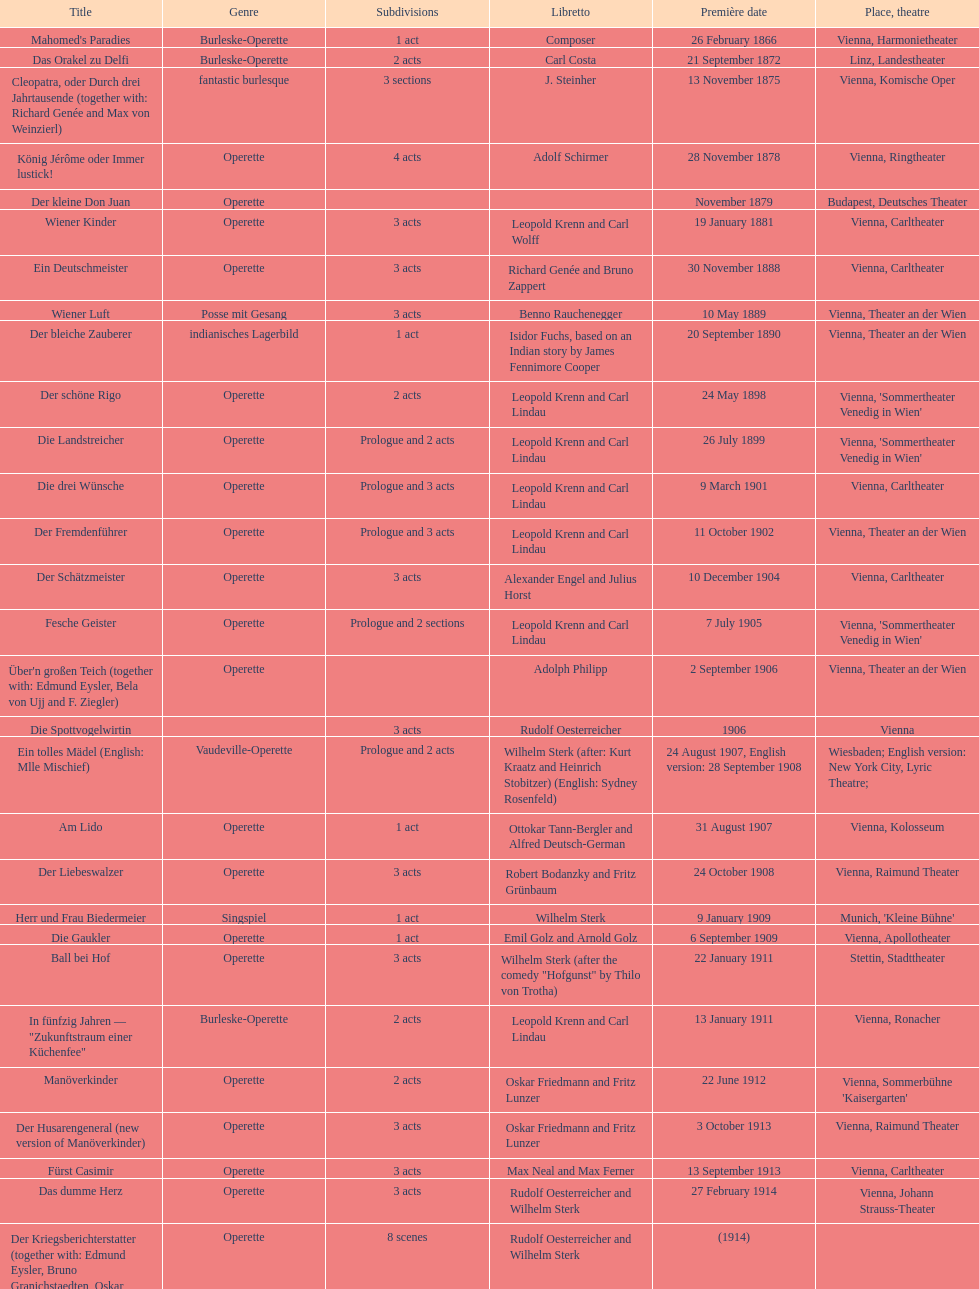What is the count of his operettas that have 3 acts? 13. 